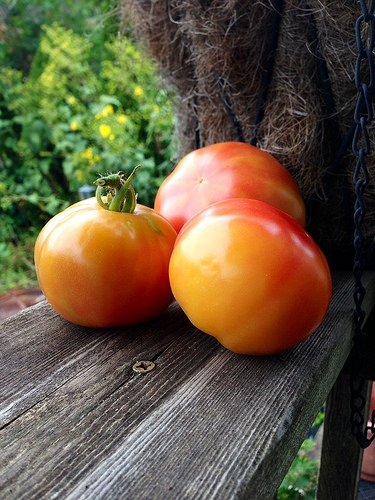<image>
Is there a tomato behind the tomato? Yes. From this viewpoint, the tomato is positioned behind the tomato, with the tomato partially or fully occluding the tomato. 